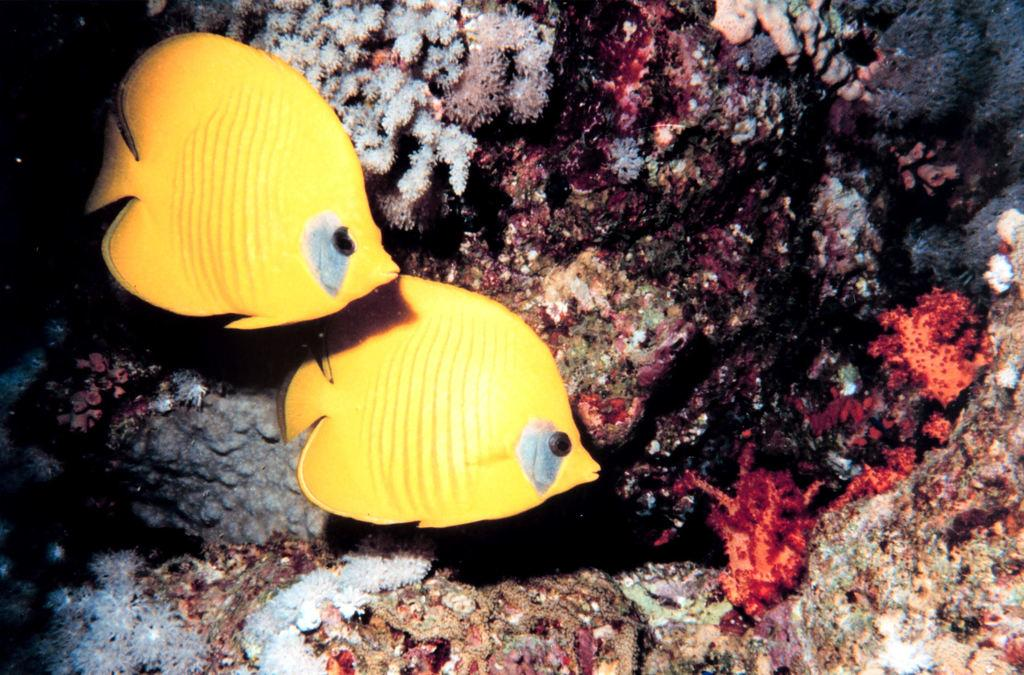How many fish are in the image? There are two fish in the image. What are the fish doing in the image? The fish are swimming in the water. What color are the fish? The fish are yellow in color. What can be seen in the background of the image? There are stones visible in the background of the image. What news is being reported by the fish in the image? There is no news being reported in the image; it features two yellow fish swimming in the water. How many parcels are being delivered by the fish in the image? There are no parcels being delivered in the image; it features two yellow fish swimming in the water. 